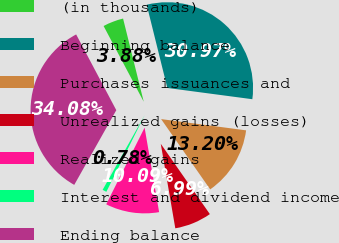Convert chart to OTSL. <chart><loc_0><loc_0><loc_500><loc_500><pie_chart><fcel>(in thousands)<fcel>Beginning balance<fcel>Purchases issuances and<fcel>Unrealized gains (losses)<fcel>Realized gains<fcel>Interest and dividend income<fcel>Ending balance<nl><fcel>3.88%<fcel>30.97%<fcel>13.2%<fcel>6.99%<fcel>10.09%<fcel>0.78%<fcel>34.08%<nl></chart> 